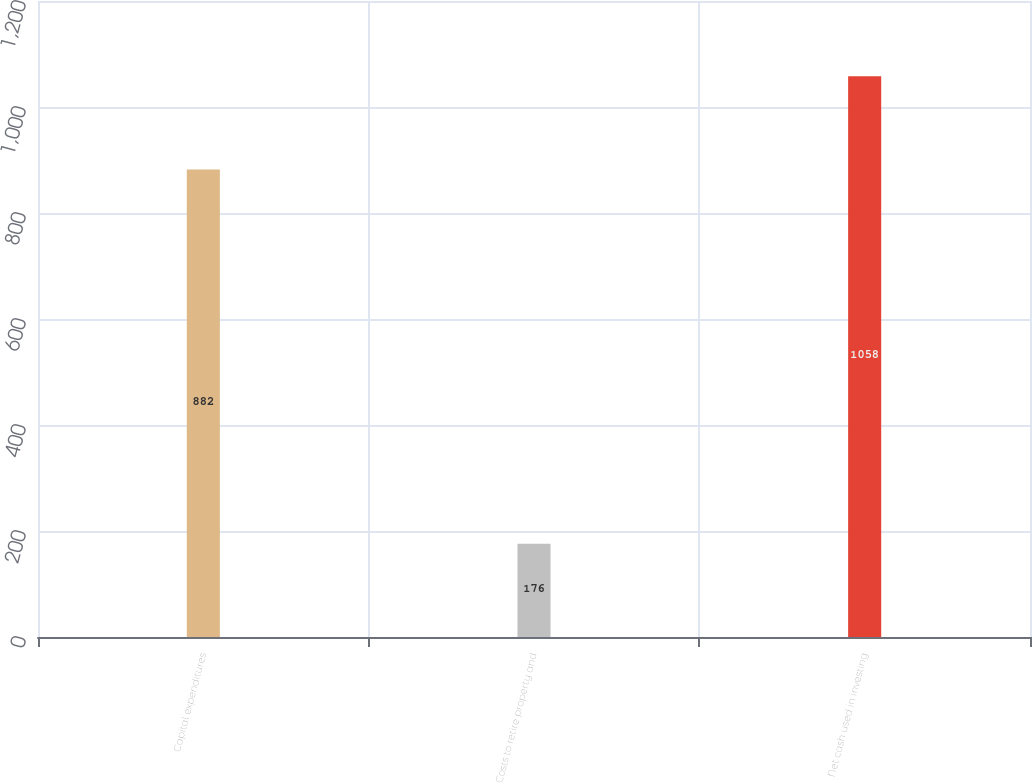Convert chart. <chart><loc_0><loc_0><loc_500><loc_500><bar_chart><fcel>Capital expenditures<fcel>Costs to retire property and<fcel>Net cash used in investing<nl><fcel>882<fcel>176<fcel>1058<nl></chart> 